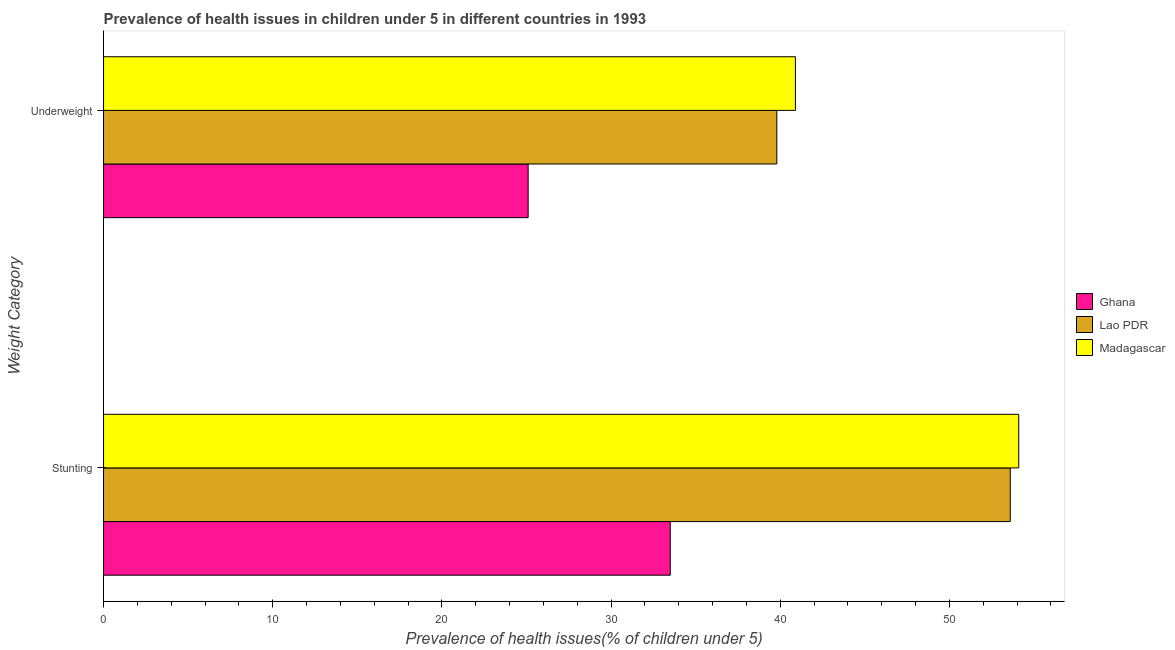How many groups of bars are there?
Give a very brief answer. 2. Are the number of bars per tick equal to the number of legend labels?
Your answer should be compact. Yes. Are the number of bars on each tick of the Y-axis equal?
Provide a succinct answer. Yes. How many bars are there on the 2nd tick from the top?
Offer a very short reply. 3. What is the label of the 2nd group of bars from the top?
Your answer should be compact. Stunting. What is the percentage of stunted children in Madagascar?
Keep it short and to the point. 54.1. Across all countries, what is the maximum percentage of underweight children?
Provide a succinct answer. 40.9. Across all countries, what is the minimum percentage of underweight children?
Offer a terse response. 25.1. In which country was the percentage of stunted children maximum?
Provide a short and direct response. Madagascar. What is the total percentage of stunted children in the graph?
Your answer should be compact. 141.2. What is the difference between the percentage of stunted children in Madagascar and that in Lao PDR?
Provide a short and direct response. 0.5. What is the difference between the percentage of stunted children in Lao PDR and the percentage of underweight children in Madagascar?
Your response must be concise. 12.7. What is the average percentage of stunted children per country?
Make the answer very short. 47.07. What is the difference between the percentage of underweight children and percentage of stunted children in Ghana?
Keep it short and to the point. -8.4. What is the ratio of the percentage of stunted children in Lao PDR to that in Madagascar?
Your answer should be very brief. 0.99. What does the 2nd bar from the top in Underweight represents?
Your answer should be very brief. Lao PDR. What does the 3rd bar from the bottom in Stunting represents?
Give a very brief answer. Madagascar. Are all the bars in the graph horizontal?
Ensure brevity in your answer.  Yes. How many countries are there in the graph?
Give a very brief answer. 3. What is the difference between two consecutive major ticks on the X-axis?
Provide a succinct answer. 10. Does the graph contain any zero values?
Your answer should be very brief. No. Does the graph contain grids?
Offer a very short reply. No. What is the title of the graph?
Provide a succinct answer. Prevalence of health issues in children under 5 in different countries in 1993. Does "Europe(developing only)" appear as one of the legend labels in the graph?
Your response must be concise. No. What is the label or title of the X-axis?
Your answer should be compact. Prevalence of health issues(% of children under 5). What is the label or title of the Y-axis?
Your answer should be very brief. Weight Category. What is the Prevalence of health issues(% of children under 5) in Ghana in Stunting?
Offer a terse response. 33.5. What is the Prevalence of health issues(% of children under 5) of Lao PDR in Stunting?
Give a very brief answer. 53.6. What is the Prevalence of health issues(% of children under 5) of Madagascar in Stunting?
Give a very brief answer. 54.1. What is the Prevalence of health issues(% of children under 5) of Ghana in Underweight?
Give a very brief answer. 25.1. What is the Prevalence of health issues(% of children under 5) of Lao PDR in Underweight?
Keep it short and to the point. 39.8. What is the Prevalence of health issues(% of children under 5) of Madagascar in Underweight?
Your answer should be compact. 40.9. Across all Weight Category, what is the maximum Prevalence of health issues(% of children under 5) in Ghana?
Offer a very short reply. 33.5. Across all Weight Category, what is the maximum Prevalence of health issues(% of children under 5) in Lao PDR?
Your response must be concise. 53.6. Across all Weight Category, what is the maximum Prevalence of health issues(% of children under 5) of Madagascar?
Offer a very short reply. 54.1. Across all Weight Category, what is the minimum Prevalence of health issues(% of children under 5) in Ghana?
Your answer should be compact. 25.1. Across all Weight Category, what is the minimum Prevalence of health issues(% of children under 5) in Lao PDR?
Provide a succinct answer. 39.8. Across all Weight Category, what is the minimum Prevalence of health issues(% of children under 5) of Madagascar?
Provide a short and direct response. 40.9. What is the total Prevalence of health issues(% of children under 5) of Ghana in the graph?
Offer a very short reply. 58.6. What is the total Prevalence of health issues(% of children under 5) of Lao PDR in the graph?
Your answer should be very brief. 93.4. What is the total Prevalence of health issues(% of children under 5) of Madagascar in the graph?
Provide a short and direct response. 95. What is the difference between the Prevalence of health issues(% of children under 5) of Lao PDR in Stunting and that in Underweight?
Your response must be concise. 13.8. What is the difference between the Prevalence of health issues(% of children under 5) in Lao PDR in Stunting and the Prevalence of health issues(% of children under 5) in Madagascar in Underweight?
Your response must be concise. 12.7. What is the average Prevalence of health issues(% of children under 5) in Ghana per Weight Category?
Your response must be concise. 29.3. What is the average Prevalence of health issues(% of children under 5) in Lao PDR per Weight Category?
Offer a very short reply. 46.7. What is the average Prevalence of health issues(% of children under 5) of Madagascar per Weight Category?
Offer a very short reply. 47.5. What is the difference between the Prevalence of health issues(% of children under 5) in Ghana and Prevalence of health issues(% of children under 5) in Lao PDR in Stunting?
Keep it short and to the point. -20.1. What is the difference between the Prevalence of health issues(% of children under 5) of Ghana and Prevalence of health issues(% of children under 5) of Madagascar in Stunting?
Provide a short and direct response. -20.6. What is the difference between the Prevalence of health issues(% of children under 5) of Ghana and Prevalence of health issues(% of children under 5) of Lao PDR in Underweight?
Keep it short and to the point. -14.7. What is the difference between the Prevalence of health issues(% of children under 5) of Ghana and Prevalence of health issues(% of children under 5) of Madagascar in Underweight?
Ensure brevity in your answer.  -15.8. What is the ratio of the Prevalence of health issues(% of children under 5) in Ghana in Stunting to that in Underweight?
Provide a short and direct response. 1.33. What is the ratio of the Prevalence of health issues(% of children under 5) of Lao PDR in Stunting to that in Underweight?
Your response must be concise. 1.35. What is the ratio of the Prevalence of health issues(% of children under 5) in Madagascar in Stunting to that in Underweight?
Provide a succinct answer. 1.32. What is the difference between the highest and the second highest Prevalence of health issues(% of children under 5) in Lao PDR?
Provide a short and direct response. 13.8. What is the difference between the highest and the second highest Prevalence of health issues(% of children under 5) of Madagascar?
Your answer should be very brief. 13.2. What is the difference between the highest and the lowest Prevalence of health issues(% of children under 5) of Lao PDR?
Keep it short and to the point. 13.8. What is the difference between the highest and the lowest Prevalence of health issues(% of children under 5) in Madagascar?
Ensure brevity in your answer.  13.2. 